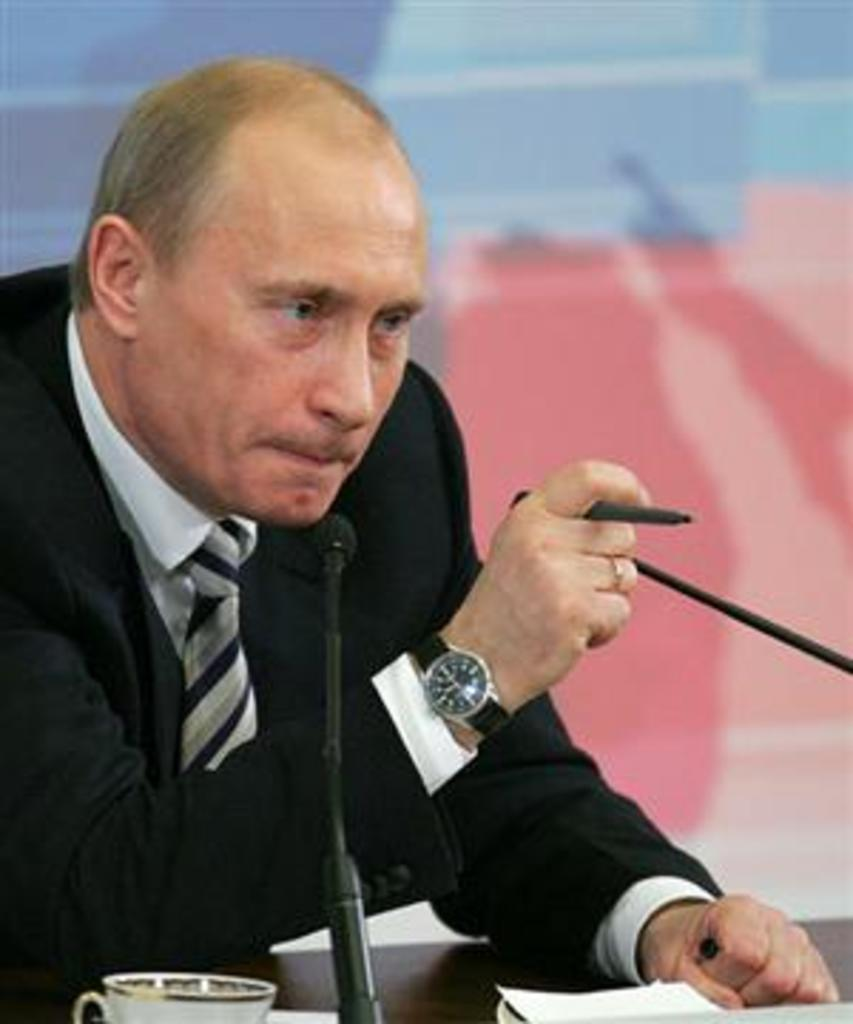What is the person in the image doing? The person is sitting on a chair in the image. What is in front of the person? There is a table in front of the person. What can be seen on the table? There is a cup, papers, and microphones (mics) on the table. Can you describe the background of the image? The background of the image is blurred. What type of bone is visible on the table in the image? There is no bone present on the table in the image. What kind of vessel is being used by the person in the image? The image does not show any vessels being used by the person; it only shows a cup on the table. 